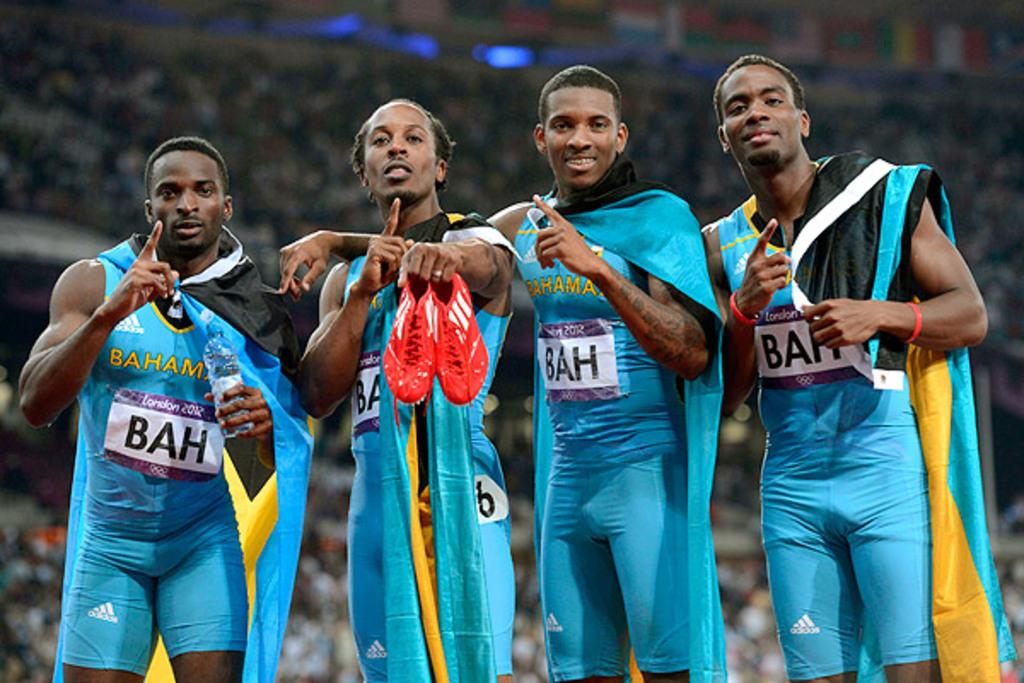<image>
Describe the image concisely. Four runners from the Bahamas at the London 2012 Olympics. 